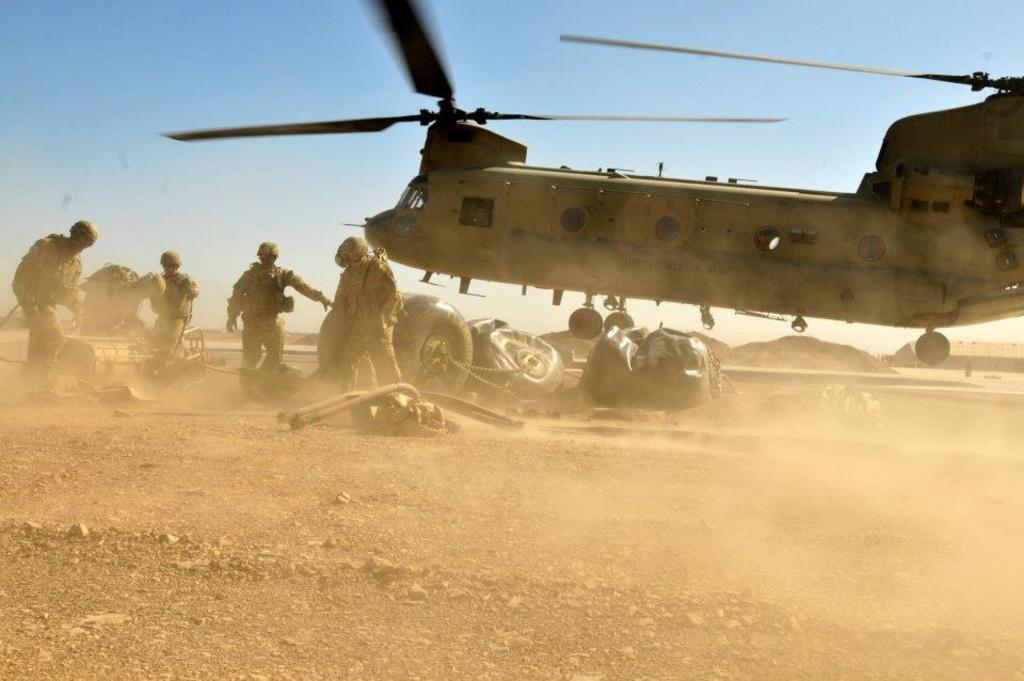Can you describe this image briefly? In this image there is a military helicopter flying, there are group of people standing, there are some items on the ground ,and in the background there is a house and sky. 